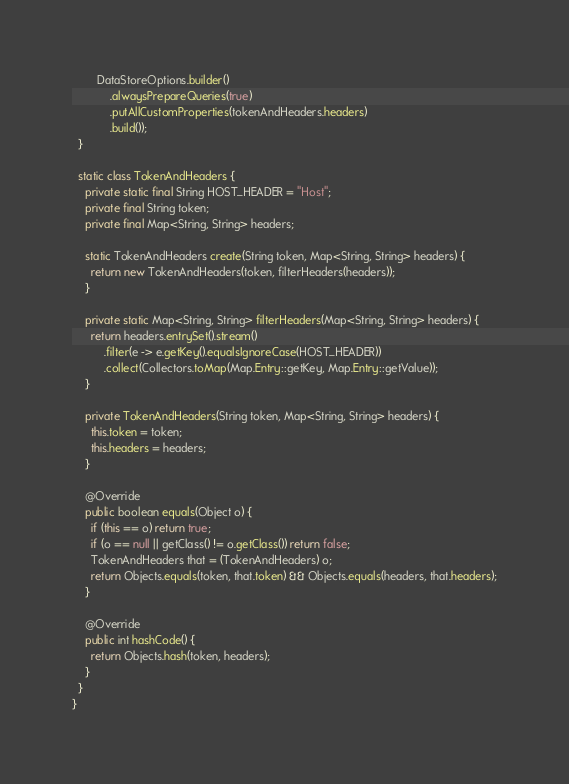<code> <loc_0><loc_0><loc_500><loc_500><_Java_>        DataStoreOptions.builder()
            .alwaysPrepareQueries(true)
            .putAllCustomProperties(tokenAndHeaders.headers)
            .build());
  }

  static class TokenAndHeaders {
    private static final String HOST_HEADER = "Host";
    private final String token;
    private final Map<String, String> headers;

    static TokenAndHeaders create(String token, Map<String, String> headers) {
      return new TokenAndHeaders(token, filterHeaders(headers));
    }

    private static Map<String, String> filterHeaders(Map<String, String> headers) {
      return headers.entrySet().stream()
          .filter(e -> e.getKey().equalsIgnoreCase(HOST_HEADER))
          .collect(Collectors.toMap(Map.Entry::getKey, Map.Entry::getValue));
    }

    private TokenAndHeaders(String token, Map<String, String> headers) {
      this.token = token;
      this.headers = headers;
    }

    @Override
    public boolean equals(Object o) {
      if (this == o) return true;
      if (o == null || getClass() != o.getClass()) return false;
      TokenAndHeaders that = (TokenAndHeaders) o;
      return Objects.equals(token, that.token) && Objects.equals(headers, that.headers);
    }

    @Override
    public int hashCode() {
      return Objects.hash(token, headers);
    }
  }
}
</code> 